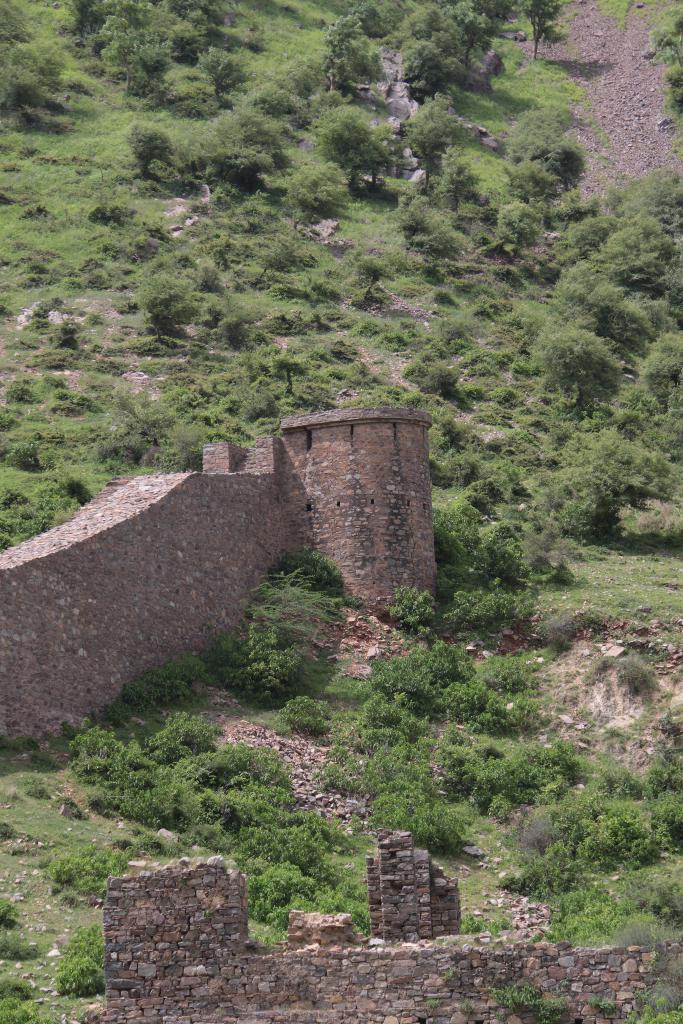Could you give a brief overview of what you see in this image? This is an outside view. At the bottom of the image there is a wall. On the left side, I can see a port. Around this I can see many plants and trees on the ground. 